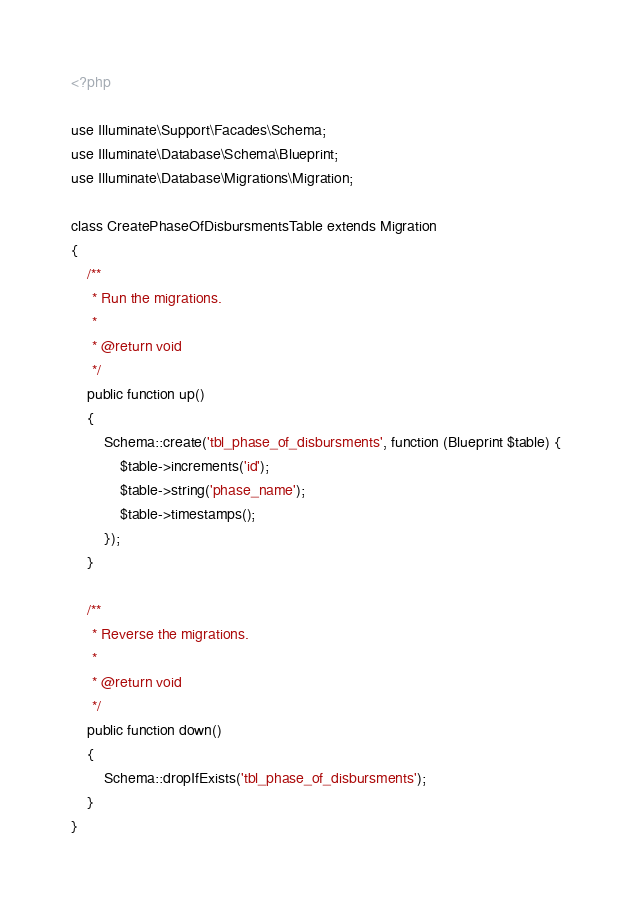Convert code to text. <code><loc_0><loc_0><loc_500><loc_500><_PHP_><?php

use Illuminate\Support\Facades\Schema;
use Illuminate\Database\Schema\Blueprint;
use Illuminate\Database\Migrations\Migration;

class CreatePhaseOfDisbursmentsTable extends Migration
{
    /**
     * Run the migrations.
     *
     * @return void
     */
    public function up()
    {
        Schema::create('tbl_phase_of_disbursments', function (Blueprint $table) {
            $table->increments('id');
            $table->string('phase_name');
            $table->timestamps();
        });
    }

    /**
     * Reverse the migrations.
     *
     * @return void
     */
    public function down()
    {
        Schema::dropIfExists('tbl_phase_of_disbursments');
    }
}
</code> 